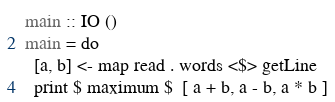<code> <loc_0><loc_0><loc_500><loc_500><_Haskell_>main :: IO ()
main = do
  [a, b] <- map read . words <$> getLine
  print $ maximum $  [ a + b, a - b, a * b ]
</code> 